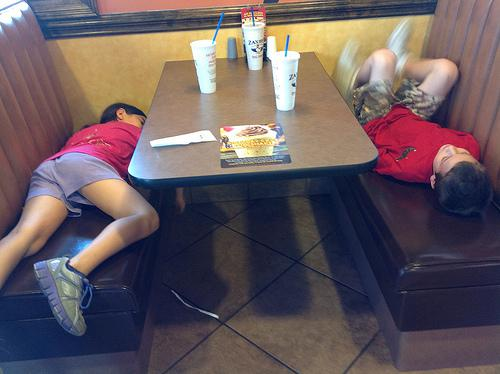Question: what are the children laying on?
Choices:
A. A blanket.
B. Booth.
C. The ground.
D. The couch.
Answer with the letter. Answer: B Question: what color shirt are the kids wearing?
Choices:
A. Blue.
B. Red.
C. Green.
D. Yellow.
Answer with the letter. Answer: B Question: how many children are pictured?
Choices:
A. 4.
B. 5.
C. 2.
D. 6.
Answer with the letter. Answer: C Question: who is kicking their feet?
Choices:
A. The littlest boy.
B. Boy on right.
C. The girl.
D. The boy in the middle.
Answer with the letter. Answer: B 